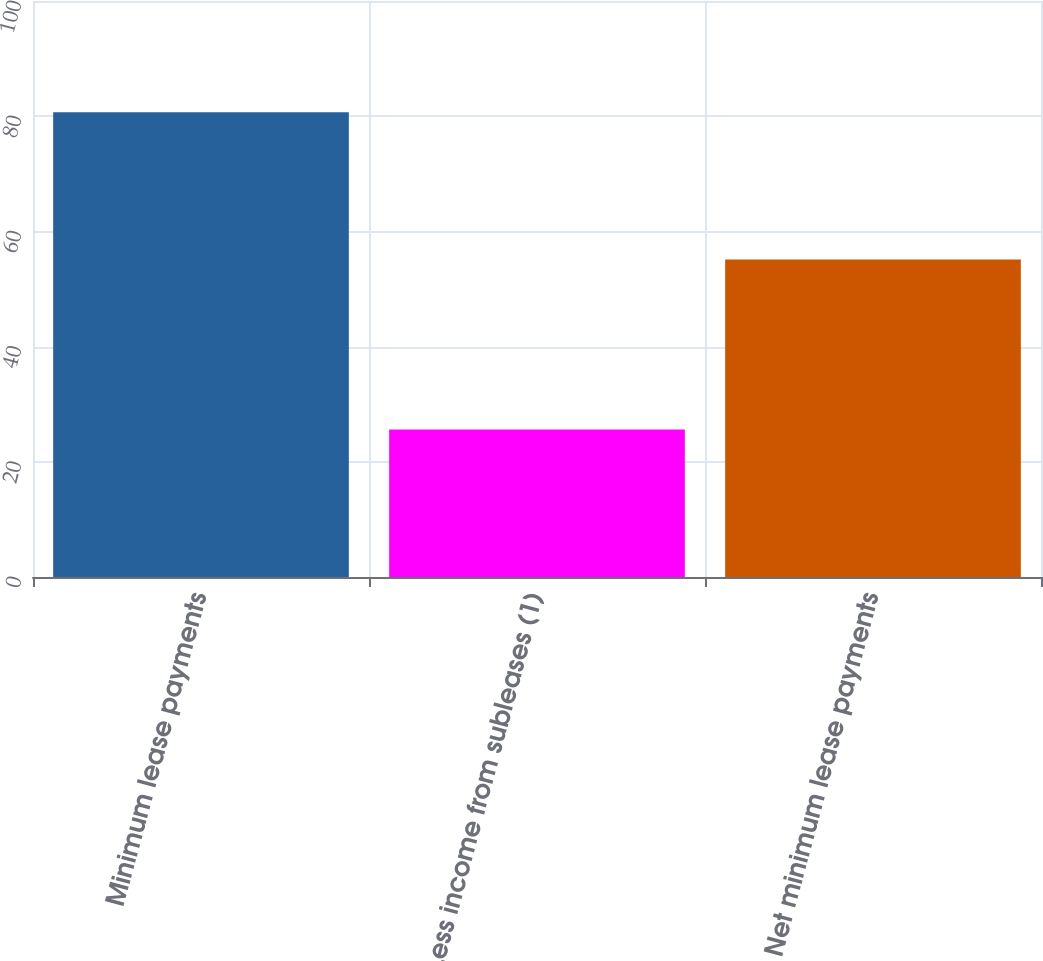Convert chart. <chart><loc_0><loc_0><loc_500><loc_500><bar_chart><fcel>Minimum lease payments<fcel>Less income from subleases (1)<fcel>Net minimum lease payments<nl><fcel>80.7<fcel>25.6<fcel>55.1<nl></chart> 